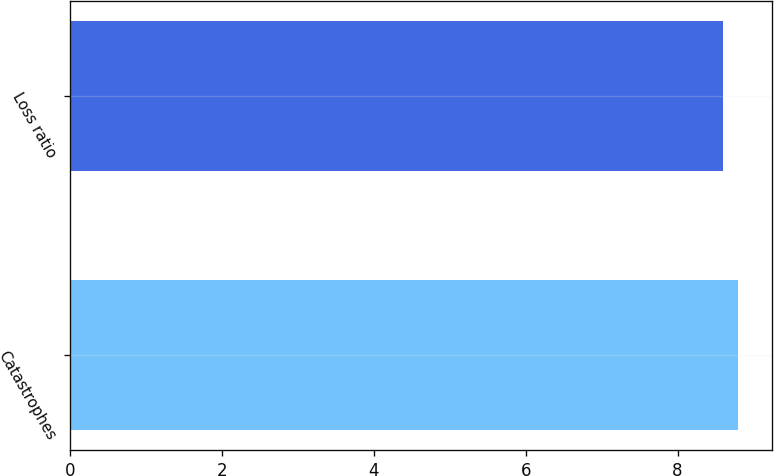<chart> <loc_0><loc_0><loc_500><loc_500><bar_chart><fcel>Catastrophes<fcel>Loss ratio<nl><fcel>8.8<fcel>8.6<nl></chart> 